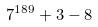<formula> <loc_0><loc_0><loc_500><loc_500>7 ^ { 1 8 9 } + 3 - 8</formula> 